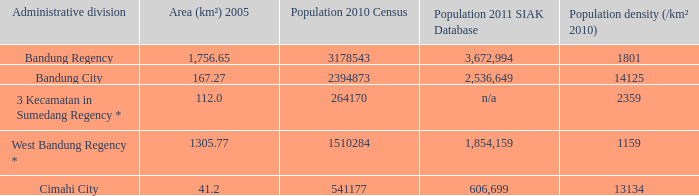Which administrative division had a population of 2011 according to the siak database of 3,672,994? Bandung Regency. 